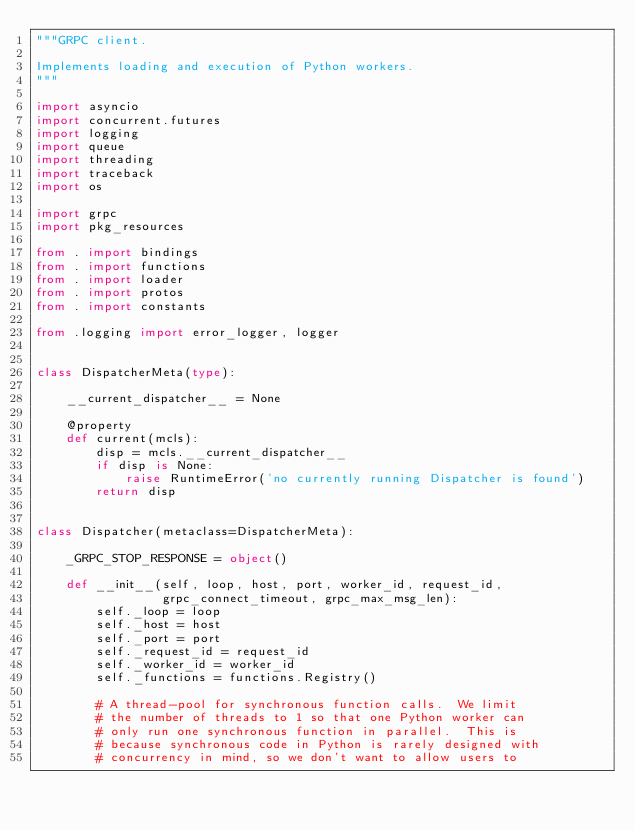<code> <loc_0><loc_0><loc_500><loc_500><_Python_>"""GRPC client.

Implements loading and execution of Python workers.
"""

import asyncio
import concurrent.futures
import logging
import queue
import threading
import traceback
import os

import grpc
import pkg_resources

from . import bindings
from . import functions
from . import loader
from . import protos
from . import constants

from .logging import error_logger, logger


class DispatcherMeta(type):

    __current_dispatcher__ = None

    @property
    def current(mcls):
        disp = mcls.__current_dispatcher__
        if disp is None:
            raise RuntimeError('no currently running Dispatcher is found')
        return disp


class Dispatcher(metaclass=DispatcherMeta):

    _GRPC_STOP_RESPONSE = object()

    def __init__(self, loop, host, port, worker_id, request_id,
                 grpc_connect_timeout, grpc_max_msg_len):
        self._loop = loop
        self._host = host
        self._port = port
        self._request_id = request_id
        self._worker_id = worker_id
        self._functions = functions.Registry()

        # A thread-pool for synchronous function calls.  We limit
        # the number of threads to 1 so that one Python worker can
        # only run one synchronous function in parallel.  This is
        # because synchronous code in Python is rarely designed with
        # concurrency in mind, so we don't want to allow users to</code> 